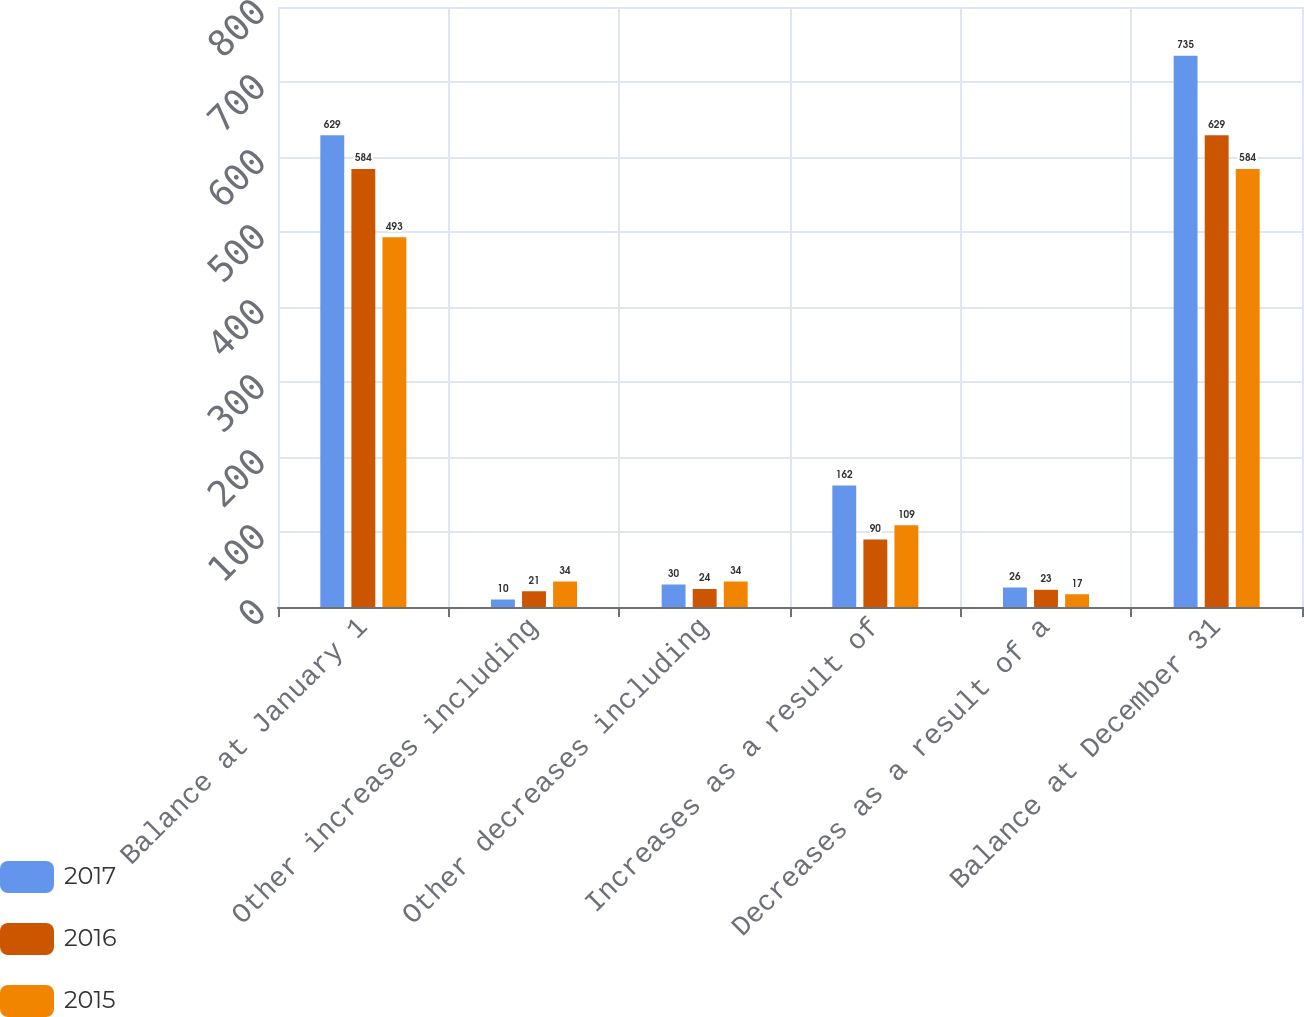Convert chart to OTSL. <chart><loc_0><loc_0><loc_500><loc_500><stacked_bar_chart><ecel><fcel>Balance at January 1<fcel>Other increases including<fcel>Other decreases including<fcel>Increases as a result of<fcel>Decreases as a result of a<fcel>Balance at December 31<nl><fcel>2017<fcel>629<fcel>10<fcel>30<fcel>162<fcel>26<fcel>735<nl><fcel>2016<fcel>584<fcel>21<fcel>24<fcel>90<fcel>23<fcel>629<nl><fcel>2015<fcel>493<fcel>34<fcel>34<fcel>109<fcel>17<fcel>584<nl></chart> 